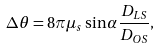Convert formula to latex. <formula><loc_0><loc_0><loc_500><loc_500>\Delta \theta = 8 \pi \mu _ { s } \sin \alpha \frac { D _ { L S } } { D _ { O S } } ,</formula> 